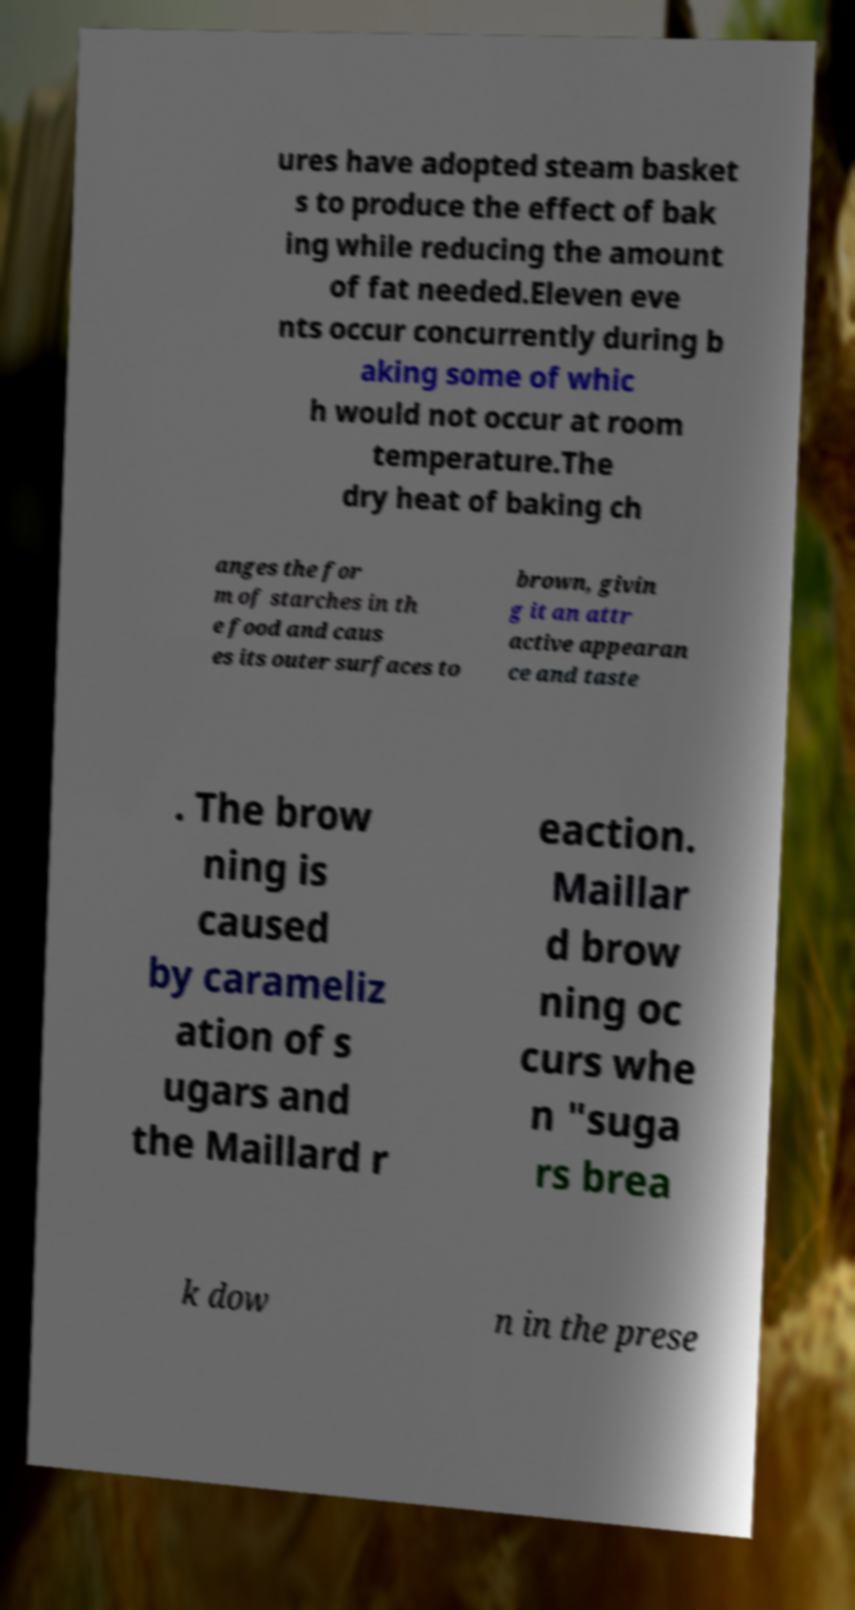Could you extract and type out the text from this image? ures have adopted steam basket s to produce the effect of bak ing while reducing the amount of fat needed.Eleven eve nts occur concurrently during b aking some of whic h would not occur at room temperature.The dry heat of baking ch anges the for m of starches in th e food and caus es its outer surfaces to brown, givin g it an attr active appearan ce and taste . The brow ning is caused by carameliz ation of s ugars and the Maillard r eaction. Maillar d brow ning oc curs whe n "suga rs brea k dow n in the prese 